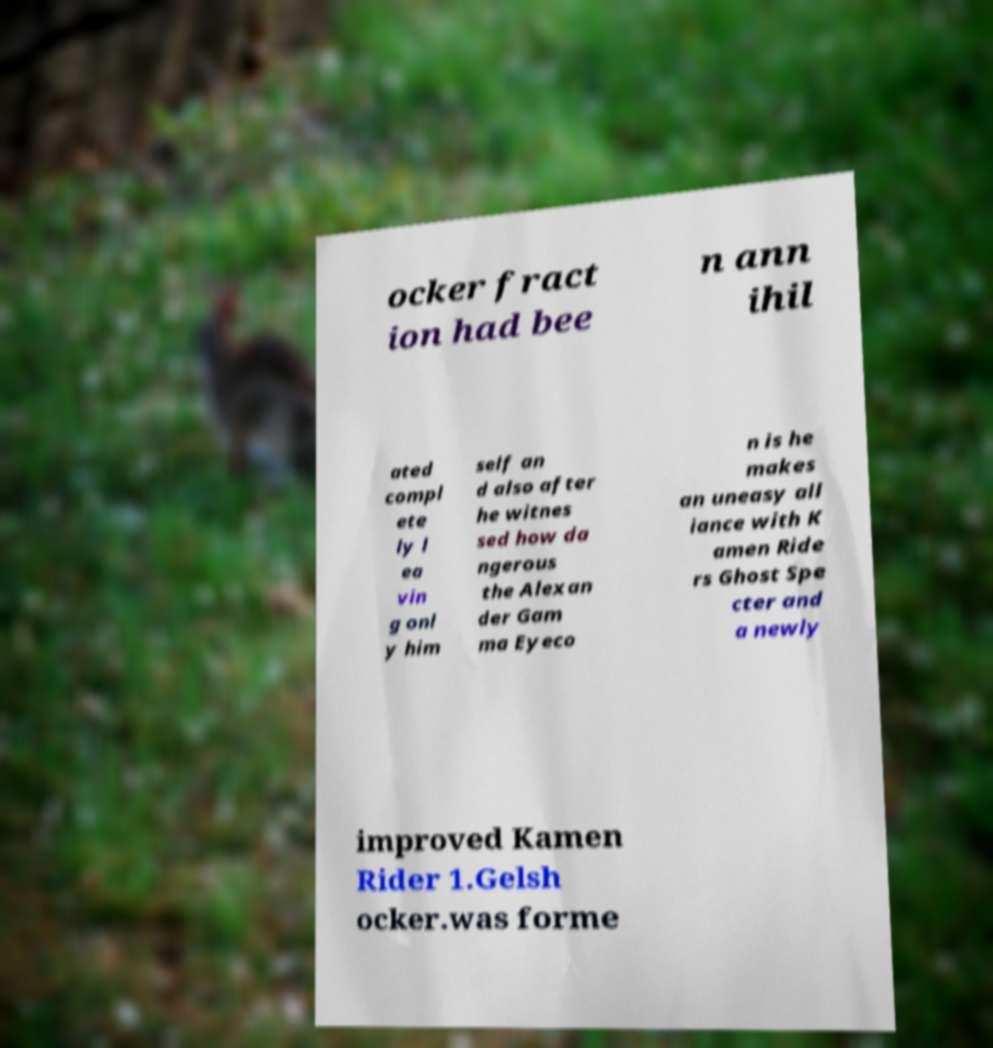Could you extract and type out the text from this image? ocker fract ion had bee n ann ihil ated compl ete ly l ea vin g onl y him self an d also after he witnes sed how da ngerous the Alexan der Gam ma Eyeco n is he makes an uneasy all iance with K amen Ride rs Ghost Spe cter and a newly improved Kamen Rider 1.Gelsh ocker.was forme 